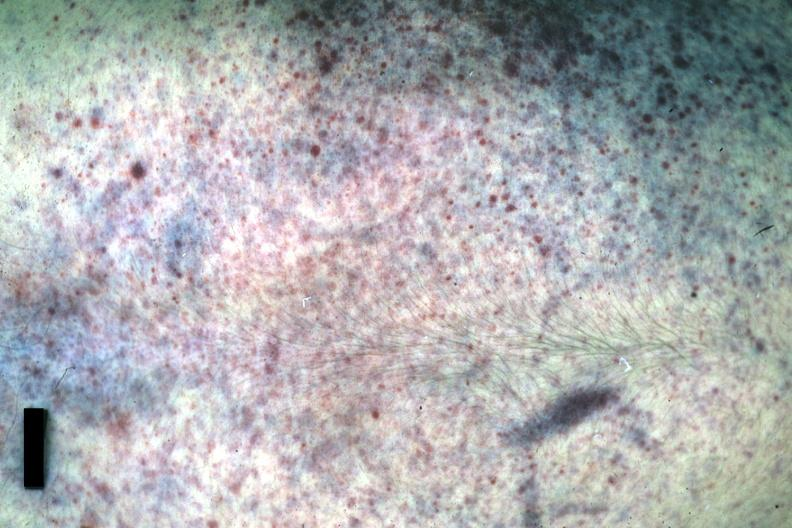what was good example either chest or posterior?
Answer the question using a single word or phrase. Anterior 